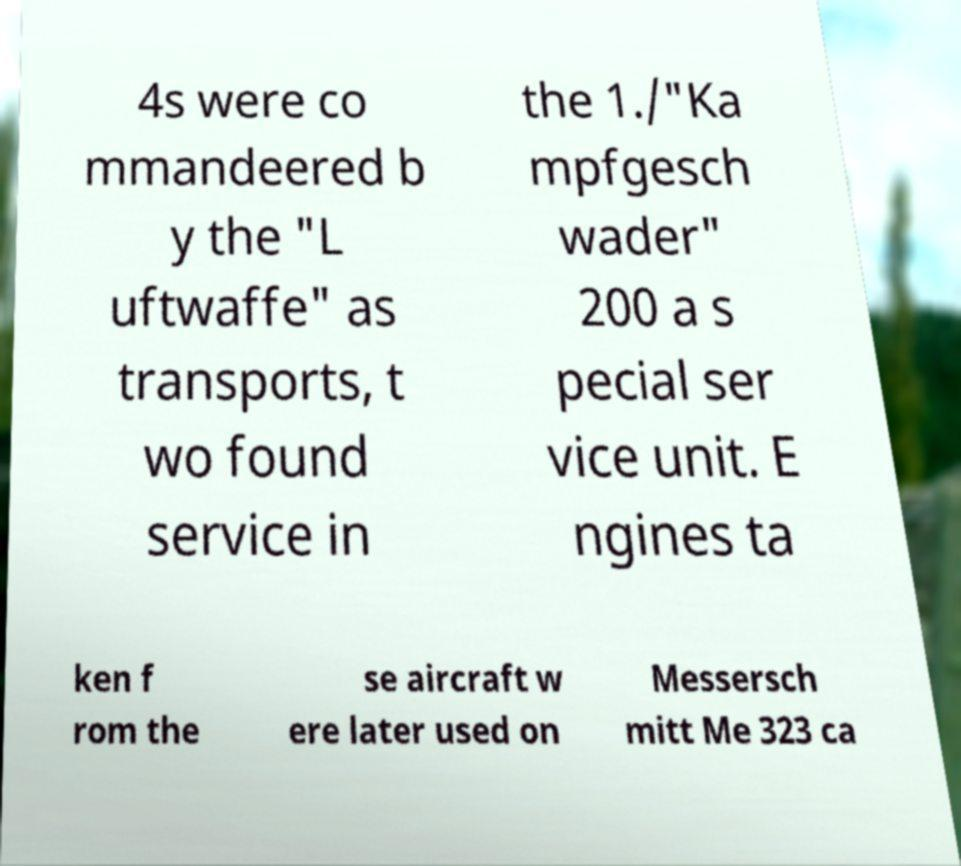Could you extract and type out the text from this image? 4s were co mmandeered b y the "L uftwaffe" as transports, t wo found service in the 1./"Ka mpfgesch wader" 200 a s pecial ser vice unit. E ngines ta ken f rom the se aircraft w ere later used on Messersch mitt Me 323 ca 